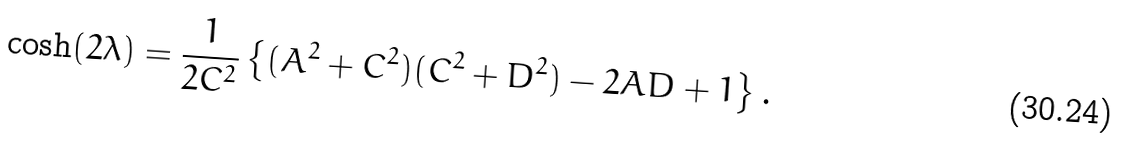<formula> <loc_0><loc_0><loc_500><loc_500>\cosh ( 2 \lambda ) = \frac { 1 } { 2 C ^ { 2 } } \left \{ ( A ^ { 2 } + C ^ { 2 } ) ( C ^ { 2 } + D ^ { 2 } ) - 2 A D + 1 \right \} .</formula> 